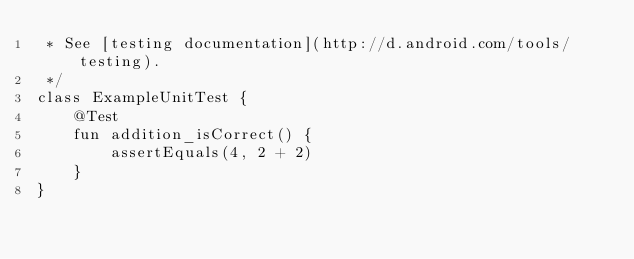<code> <loc_0><loc_0><loc_500><loc_500><_Kotlin_> * See [testing documentation](http://d.android.com/tools/testing).
 */
class ExampleUnitTest {
    @Test
    fun addition_isCorrect() {
        assertEquals(4, 2 + 2)
    }
}</code> 